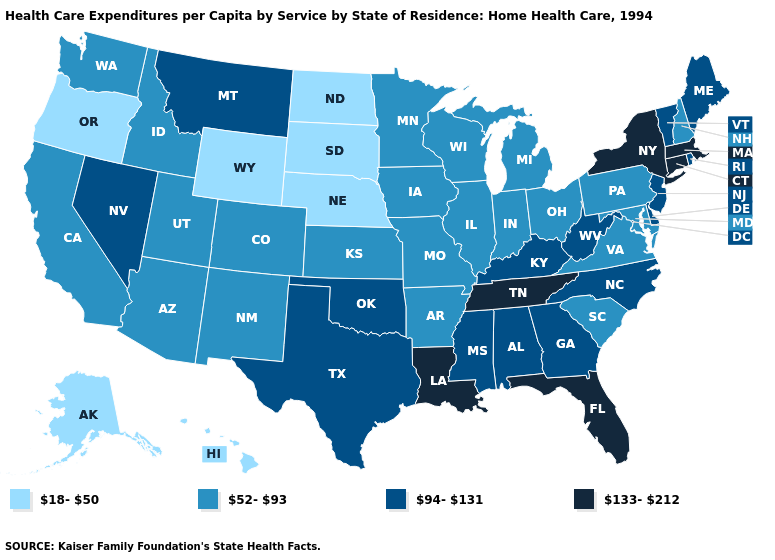Name the states that have a value in the range 94-131?
Keep it brief. Alabama, Delaware, Georgia, Kentucky, Maine, Mississippi, Montana, Nevada, New Jersey, North Carolina, Oklahoma, Rhode Island, Texas, Vermont, West Virginia. What is the value of Pennsylvania?
Keep it brief. 52-93. Does the map have missing data?
Keep it brief. No. Which states have the lowest value in the South?
Short answer required. Arkansas, Maryland, South Carolina, Virginia. Name the states that have a value in the range 133-212?
Write a very short answer. Connecticut, Florida, Louisiana, Massachusetts, New York, Tennessee. What is the lowest value in the West?
Concise answer only. 18-50. What is the value of Nebraska?
Keep it brief. 18-50. Name the states that have a value in the range 133-212?
Concise answer only. Connecticut, Florida, Louisiana, Massachusetts, New York, Tennessee. Name the states that have a value in the range 133-212?
Keep it brief. Connecticut, Florida, Louisiana, Massachusetts, New York, Tennessee. What is the lowest value in the South?
Keep it brief. 52-93. Which states have the lowest value in the USA?
Answer briefly. Alaska, Hawaii, Nebraska, North Dakota, Oregon, South Dakota, Wyoming. What is the lowest value in states that border Oklahoma?
Answer briefly. 52-93. Does Rhode Island have a lower value than Tennessee?
Quick response, please. Yes. Name the states that have a value in the range 94-131?
Concise answer only. Alabama, Delaware, Georgia, Kentucky, Maine, Mississippi, Montana, Nevada, New Jersey, North Carolina, Oklahoma, Rhode Island, Texas, Vermont, West Virginia. Does Arkansas have a lower value than Florida?
Write a very short answer. Yes. 